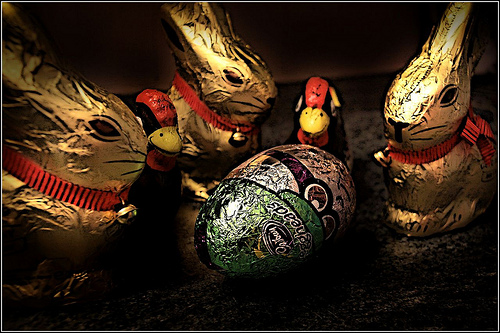<image>
Can you confirm if the chicken is in front of the egg? No. The chicken is not in front of the egg. The spatial positioning shows a different relationship between these objects. 